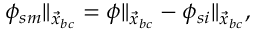<formula> <loc_0><loc_0><loc_500><loc_500>\begin{array} { r } { \phi _ { s m } \| _ { \vec { x } _ { b c } } = \phi \| _ { \vec { x } _ { b c } } - \phi _ { s i } \| _ { \vec { x } _ { b c } } , } \end{array}</formula> 